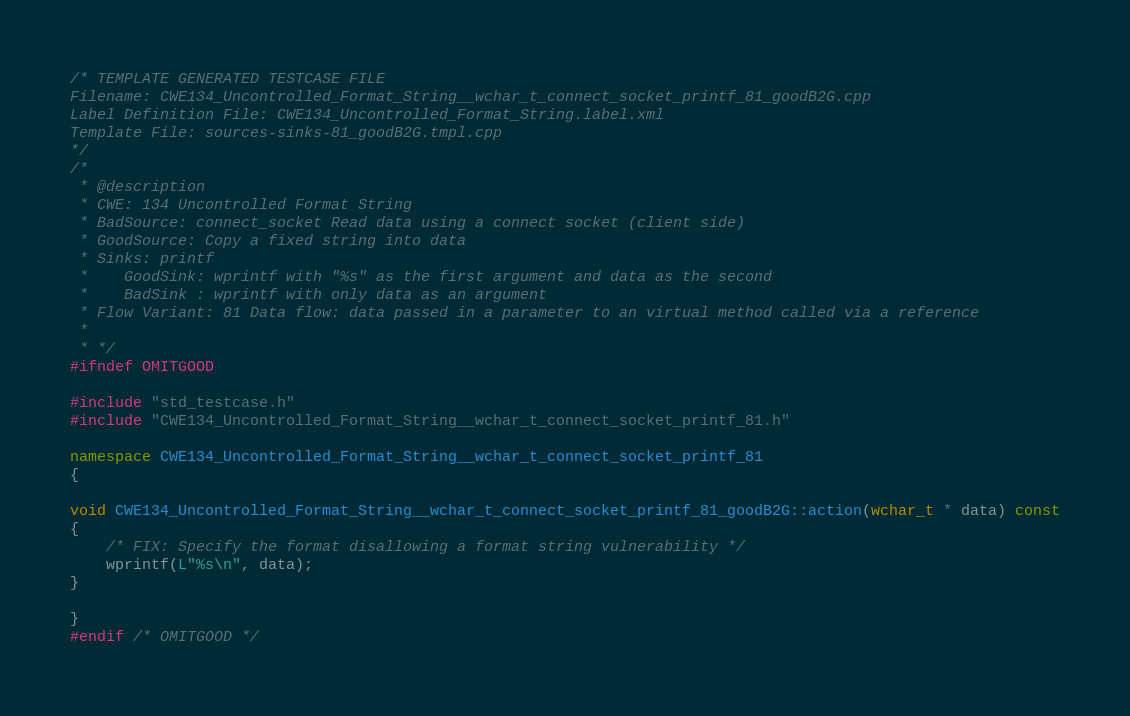<code> <loc_0><loc_0><loc_500><loc_500><_C++_>/* TEMPLATE GENERATED TESTCASE FILE
Filename: CWE134_Uncontrolled_Format_String__wchar_t_connect_socket_printf_81_goodB2G.cpp
Label Definition File: CWE134_Uncontrolled_Format_String.label.xml
Template File: sources-sinks-81_goodB2G.tmpl.cpp
*/
/*
 * @description
 * CWE: 134 Uncontrolled Format String
 * BadSource: connect_socket Read data using a connect socket (client side)
 * GoodSource: Copy a fixed string into data
 * Sinks: printf
 *    GoodSink: wprintf with "%s" as the first argument and data as the second
 *    BadSink : wprintf with only data as an argument
 * Flow Variant: 81 Data flow: data passed in a parameter to an virtual method called via a reference
 *
 * */
#ifndef OMITGOOD

#include "std_testcase.h"
#include "CWE134_Uncontrolled_Format_String__wchar_t_connect_socket_printf_81.h"

namespace CWE134_Uncontrolled_Format_String__wchar_t_connect_socket_printf_81
{

void CWE134_Uncontrolled_Format_String__wchar_t_connect_socket_printf_81_goodB2G::action(wchar_t * data) const
{
    /* FIX: Specify the format disallowing a format string vulnerability */
    wprintf(L"%s\n", data);
}

}
#endif /* OMITGOOD */
</code> 